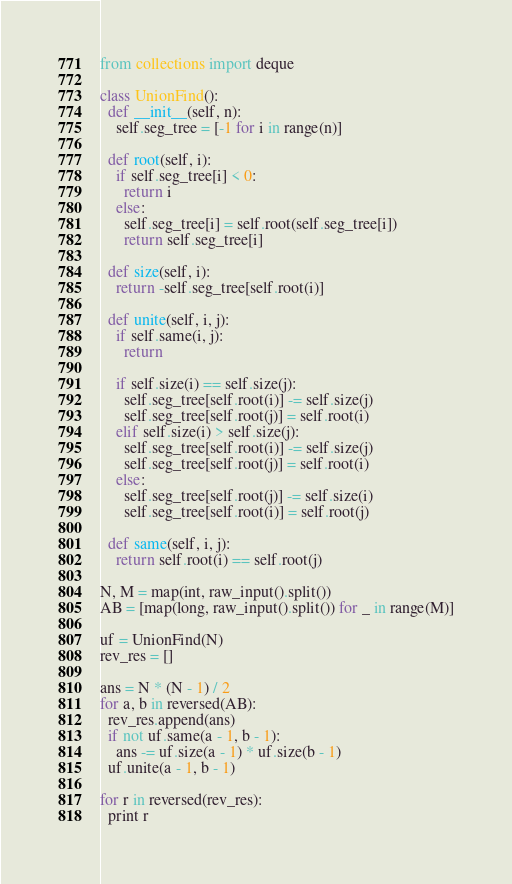Convert code to text. <code><loc_0><loc_0><loc_500><loc_500><_Python_>from collections import deque

class UnionFind():
  def __init__(self, n):
    self.seg_tree = [-1 for i in range(n)]
  
  def root(self, i):
    if self.seg_tree[i] < 0:
      return i
    else:
      self.seg_tree[i] = self.root(self.seg_tree[i])
      return self.seg_tree[i]

  def size(self, i):
    return -self.seg_tree[self.root(i)]

  def unite(self, i, j):
    if self.same(i, j):
      return

    if self.size(i) == self.size(j):
      self.seg_tree[self.root(i)] -= self.size(j)
      self.seg_tree[self.root(j)] = self.root(i)
    elif self.size(i) > self.size(j):
      self.seg_tree[self.root(i)] -= self.size(j)
      self.seg_tree[self.root(j)] = self.root(i)
    else:
      self.seg_tree[self.root(j)] -= self.size(i)
      self.seg_tree[self.root(i)] = self.root(j)

  def same(self, i, j):
    return self.root(i) == self.root(j)

N, M = map(int, raw_input().split())
AB = [map(long, raw_input().split()) for _ in range(M)]

uf = UnionFind(N)
rev_res = []

ans = N * (N - 1) / 2
for a, b in reversed(AB):
  rev_res.append(ans)
  if not uf.same(a - 1, b - 1):
    ans -= uf.size(a - 1) * uf.size(b - 1)
  uf.unite(a - 1, b - 1)

for r in reversed(rev_res):
  print r</code> 